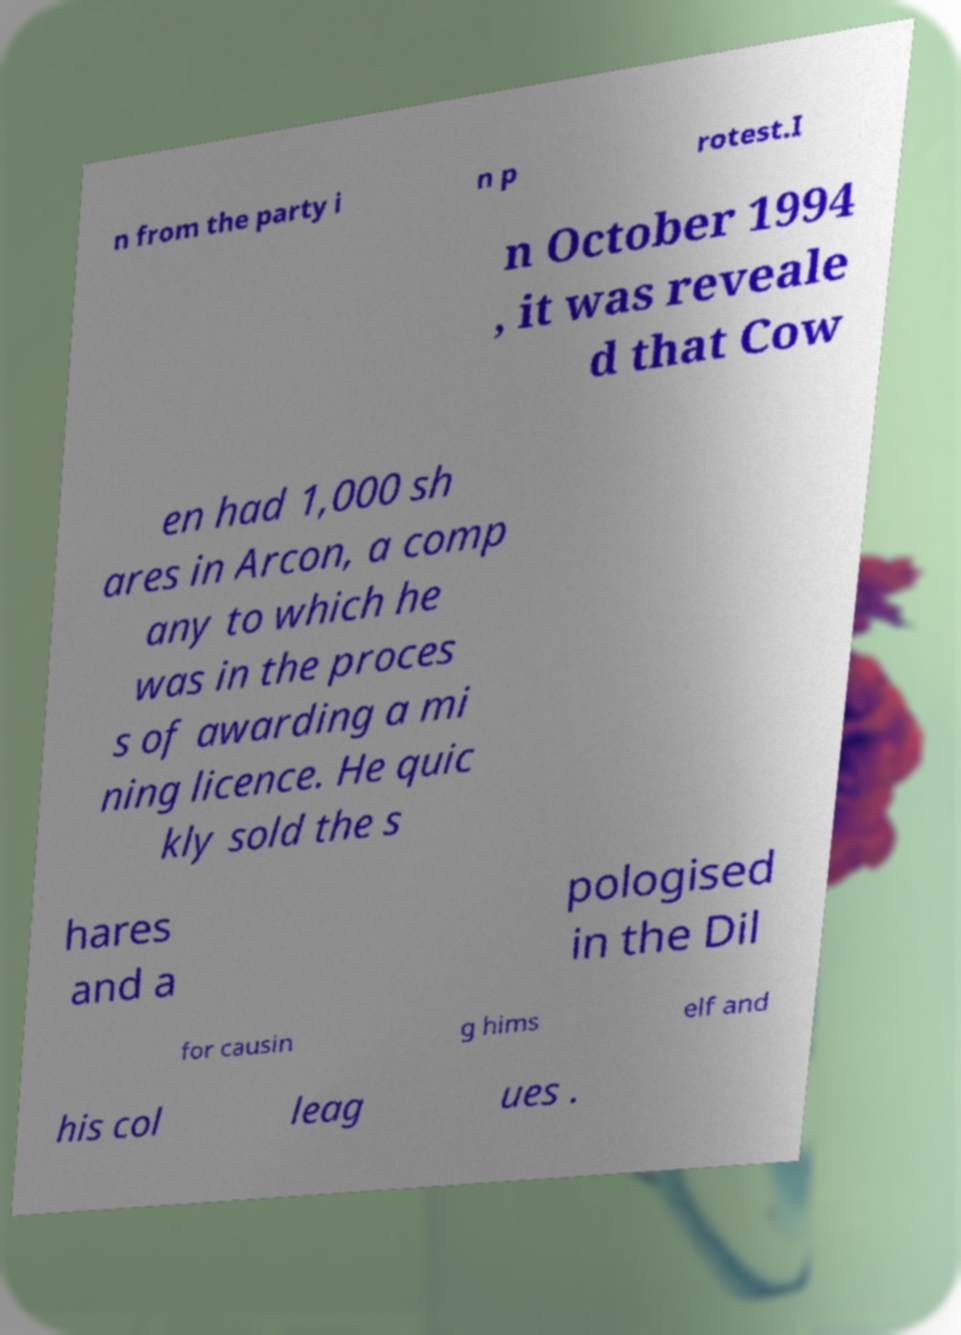What messages or text are displayed in this image? I need them in a readable, typed format. n from the party i n p rotest.I n October 1994 , it was reveale d that Cow en had 1,000 sh ares in Arcon, a comp any to which he was in the proces s of awarding a mi ning licence. He quic kly sold the s hares and a pologised in the Dil for causin g hims elf and his col leag ues . 